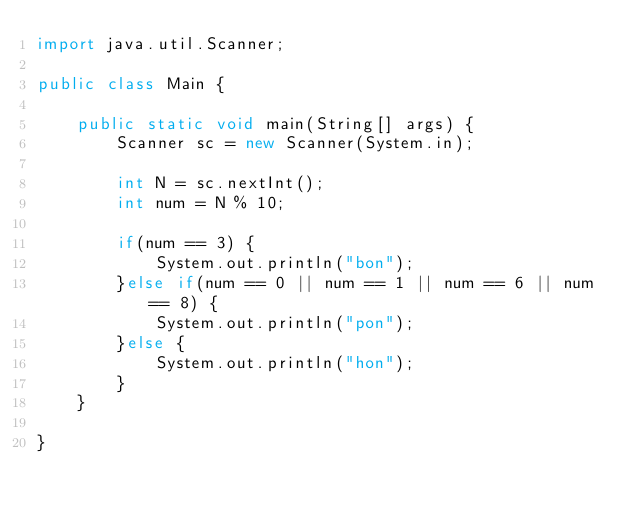Convert code to text. <code><loc_0><loc_0><loc_500><loc_500><_Java_>import java.util.Scanner;

public class Main {

	public static void main(String[] args) {
		Scanner sc = new Scanner(System.in);

		int N = sc.nextInt();
		int num = N % 10;

		if(num == 3) {
			System.out.println("bon");
		}else if(num == 0 || num == 1 || num == 6 || num == 8) {
			System.out.println("pon");
		}else {
			System.out.println("hon");
		}
	}

}</code> 